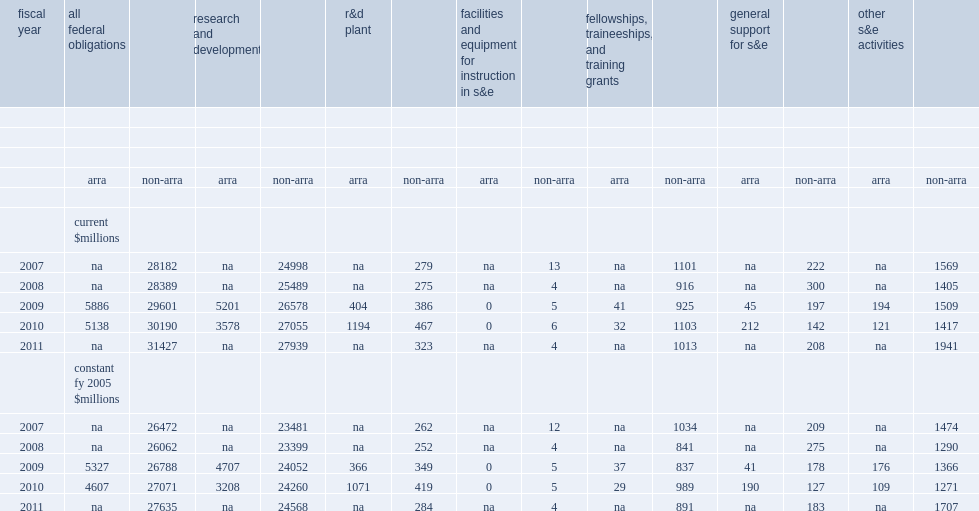In fy 2011, how many million dollars did federal agencies obligate to 1,134 academic institutions for science and engineering activities? 31427.0. How many million dollars did the last arra funds were obligated in fy 2010 and account of fy 2010 science and engineering (s&e) obligations to academic institutions? 5138.0. 